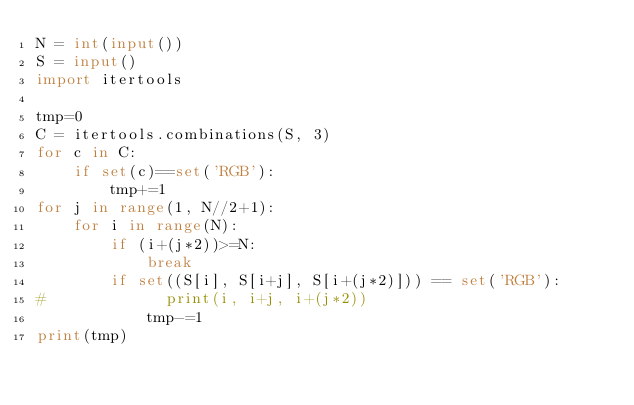<code> <loc_0><loc_0><loc_500><loc_500><_Python_>N = int(input())
S = input()
import itertools

tmp=0
C = itertools.combinations(S, 3)
for c in C:
    if set(c)==set('RGB'):
        tmp+=1
for j in range(1, N//2+1):
    for i in range(N):
        if (i+(j*2))>=N:
            break
        if set((S[i], S[i+j], S[i+(j*2)])) == set('RGB'):
#             print(i, i+j, i+(j*2))
            tmp-=1
print(tmp)</code> 